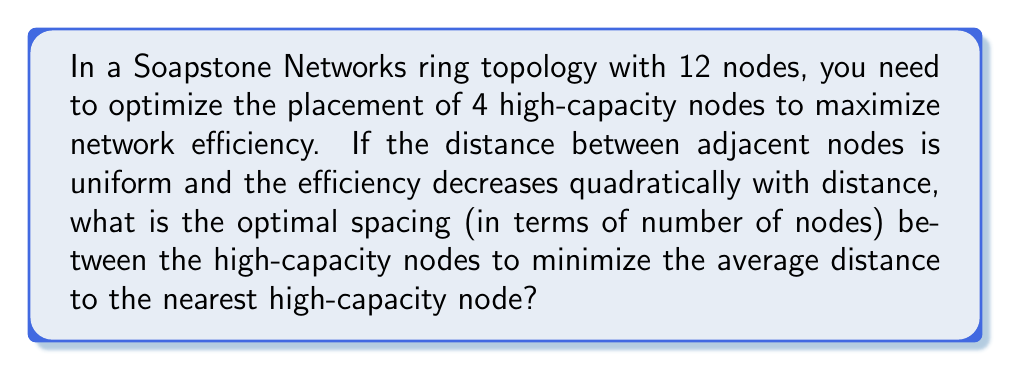Give your solution to this math problem. Let's approach this step-by-step:

1) In a ring topology with 12 nodes, we can think of the nodes as being placed at the integer points 0 to 11 on a circle.

2) We need to place 4 high-capacity nodes optimally. Due to symmetry, these should be evenly spaced.

3) Let $x$ be the number of nodes between each high-capacity node. We need to find the value of $x$ that minimizes the average distance to the nearest high-capacity node.

4) With 4 high-capacity nodes and 12 total nodes, we have the equation:
   
   $$ 4x + 4 = 12 $$
   
   This means $x = 2$, so the high-capacity nodes will be 3 nodes apart.

5) To verify this is optimal, let's calculate the average distance for $x = 2$:

   - 4 nodes (the high-capacity nodes themselves) have distance 0
   - 4 nodes have distance 1
   - 4 nodes have distance 2

   The average distance is:

   $$ \frac{4 \cdot 0^2 + 4 \cdot 1^2 + 4 \cdot 2^2}{12} = \frac{20}{12} \approx 1.67 $$

6) If we tried $x = 1$ or $x = 3$, we would get:

   For $x = 1$: $\frac{6 \cdot 0^2 + 6 \cdot 1^2}{12} = \frac{6}{12} = 0.5$
   For $x = 3$: $\frac{4 \cdot 0^2 + 4 \cdot 1^2 + 2 \cdot 2^2 + 2 \cdot 3^2}{12} = \frac{30}{12} = 2.5$

7) However, $x = 1$ is not possible because it would require 6 high-capacity nodes (12 / (1+1) = 6), which is more than the given 4.

Therefore, the optimal spacing is indeed 3 nodes apart, or $x = 2$.
Answer: The optimal spacing between high-capacity nodes is 3 nodes apart. 